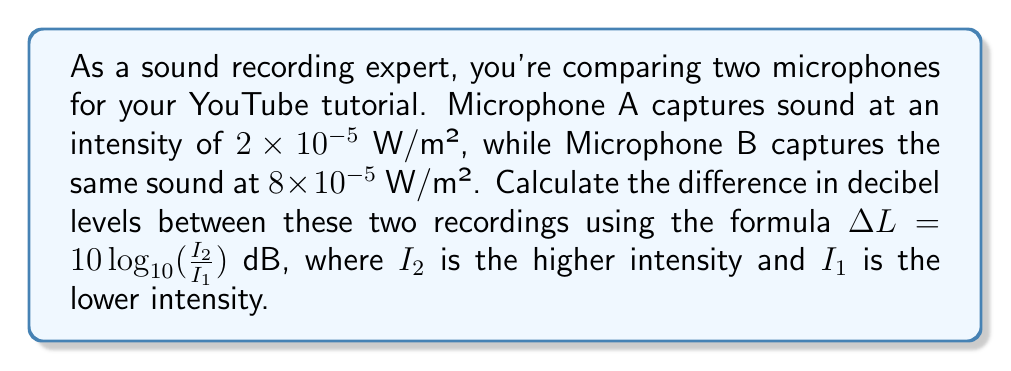Give your solution to this math problem. Let's solve this step-by-step:

1) We're given the formula: $\Delta L = 10 \log_{10}(\frac{I_2}{I_1})$ dB

2) We know:
   $I_1 = 2 \times 10^{-5}$ W/m² (Microphone A)
   $I_2 = 8 \times 10^{-5}$ W/m² (Microphone B)

3) Let's substitute these values into the formula:

   $$\Delta L = 10 \log_{10}(\frac{8 \times 10^{-5}}{2 \times 10^{-5}})$$

4) Simplify inside the parentheses:

   $$\Delta L = 10 \log_{10}(4)$$

5) Calculate the logarithm:

   $$\Delta L = 10 \times 0.60206$$

6) Multiply:

   $$\Delta L = 6.0206$$

7) Round to two decimal places:

   $$\Delta L \approx 6.02 \text{ dB}$$
Answer: 6.02 dB 